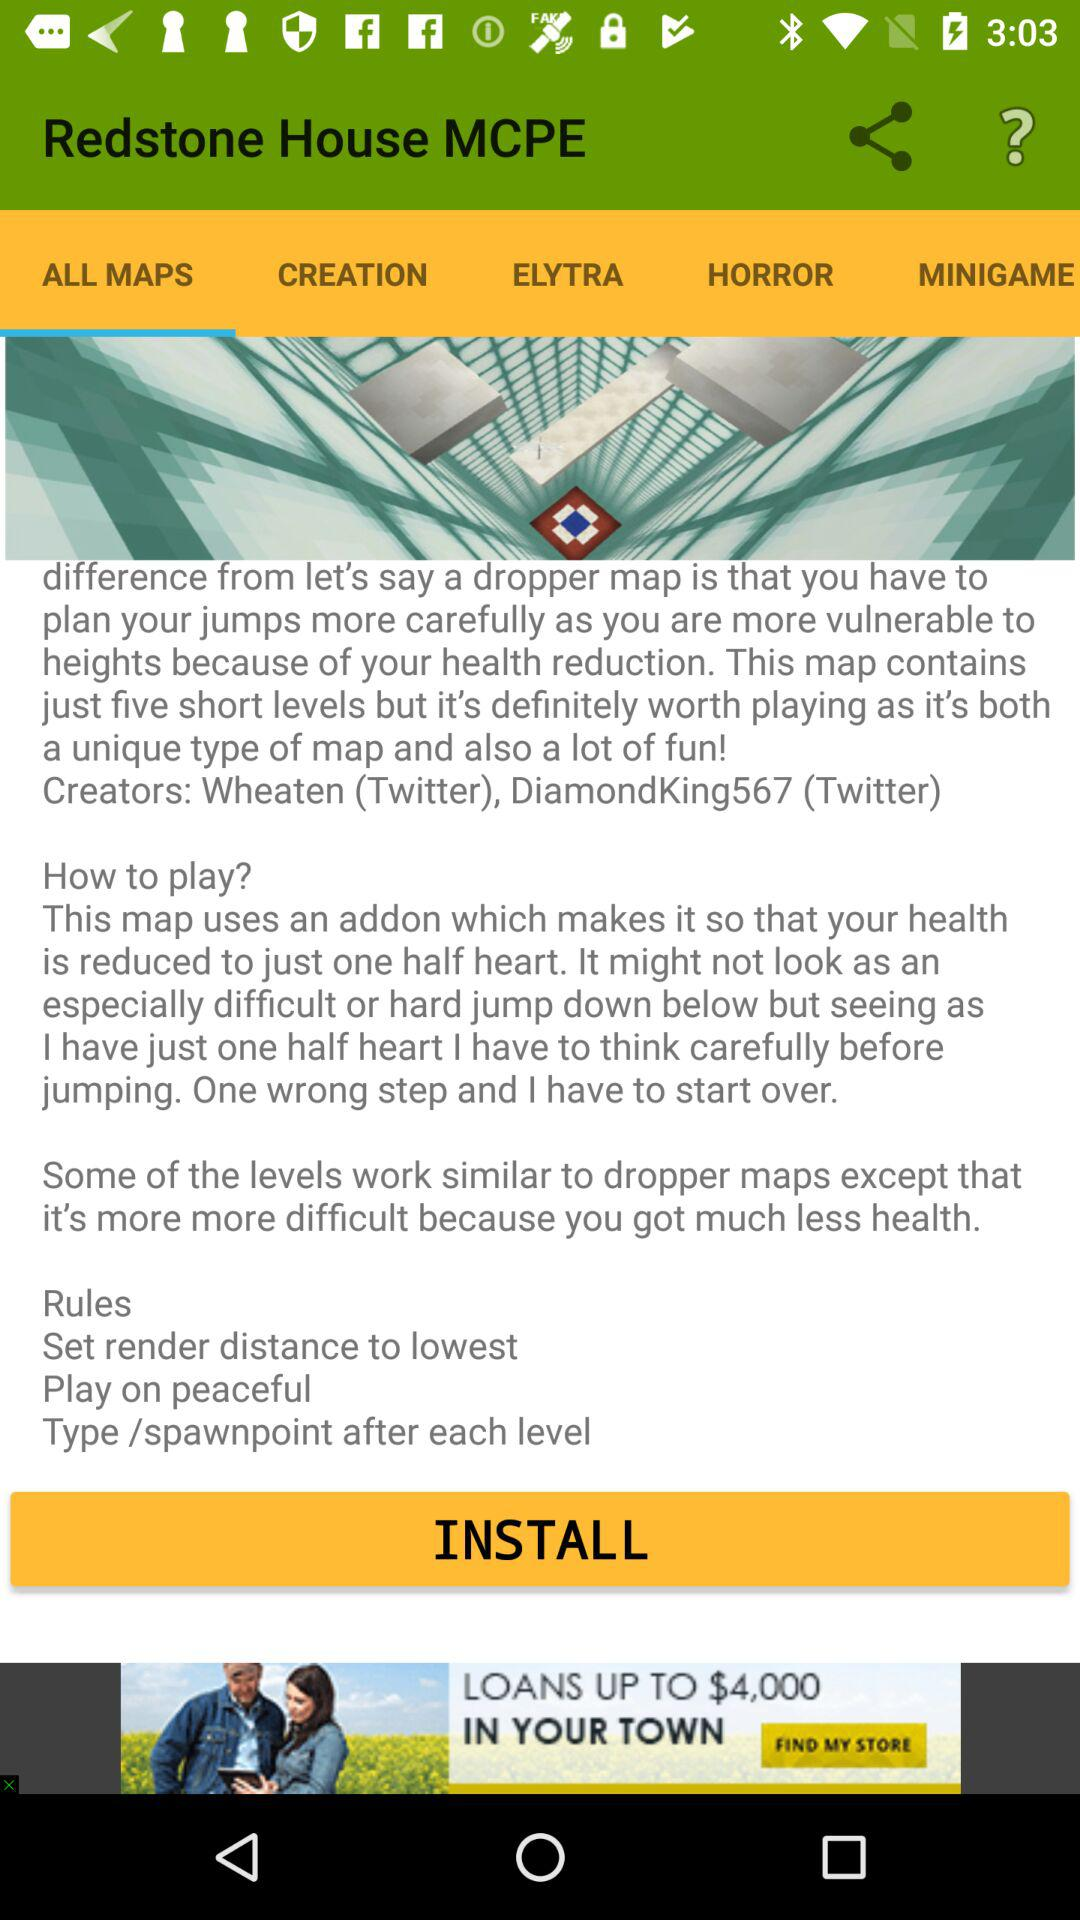Which applications are available for sharing the content?
When the provided information is insufficient, respond with <no answer>. <no answer> 